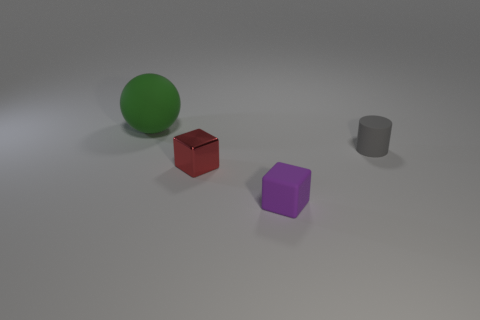There is another tiny thing that is the same shape as the small red shiny thing; what color is it?
Ensure brevity in your answer.  Purple. What number of shiny objects are left of the tiny matte object on the right side of the rubber object that is in front of the tiny gray object?
Your answer should be very brief. 1. Are there any other things that are made of the same material as the small cylinder?
Give a very brief answer. Yes. Are there fewer small matte things that are behind the tiny purple rubber thing than small blue metal balls?
Your answer should be very brief. No. Does the large matte ball have the same color as the small rubber cube?
Provide a short and direct response. No. There is a red metallic object that is the same shape as the purple matte thing; what size is it?
Your answer should be very brief. Small. What number of large balls are the same material as the small gray cylinder?
Give a very brief answer. 1. Is the material of the object that is behind the small gray thing the same as the purple block?
Provide a short and direct response. Yes. Is the number of tiny gray rubber things that are in front of the rubber cylinder the same as the number of small metallic objects?
Offer a terse response. No. How big is the purple matte thing?
Keep it short and to the point. Small. 